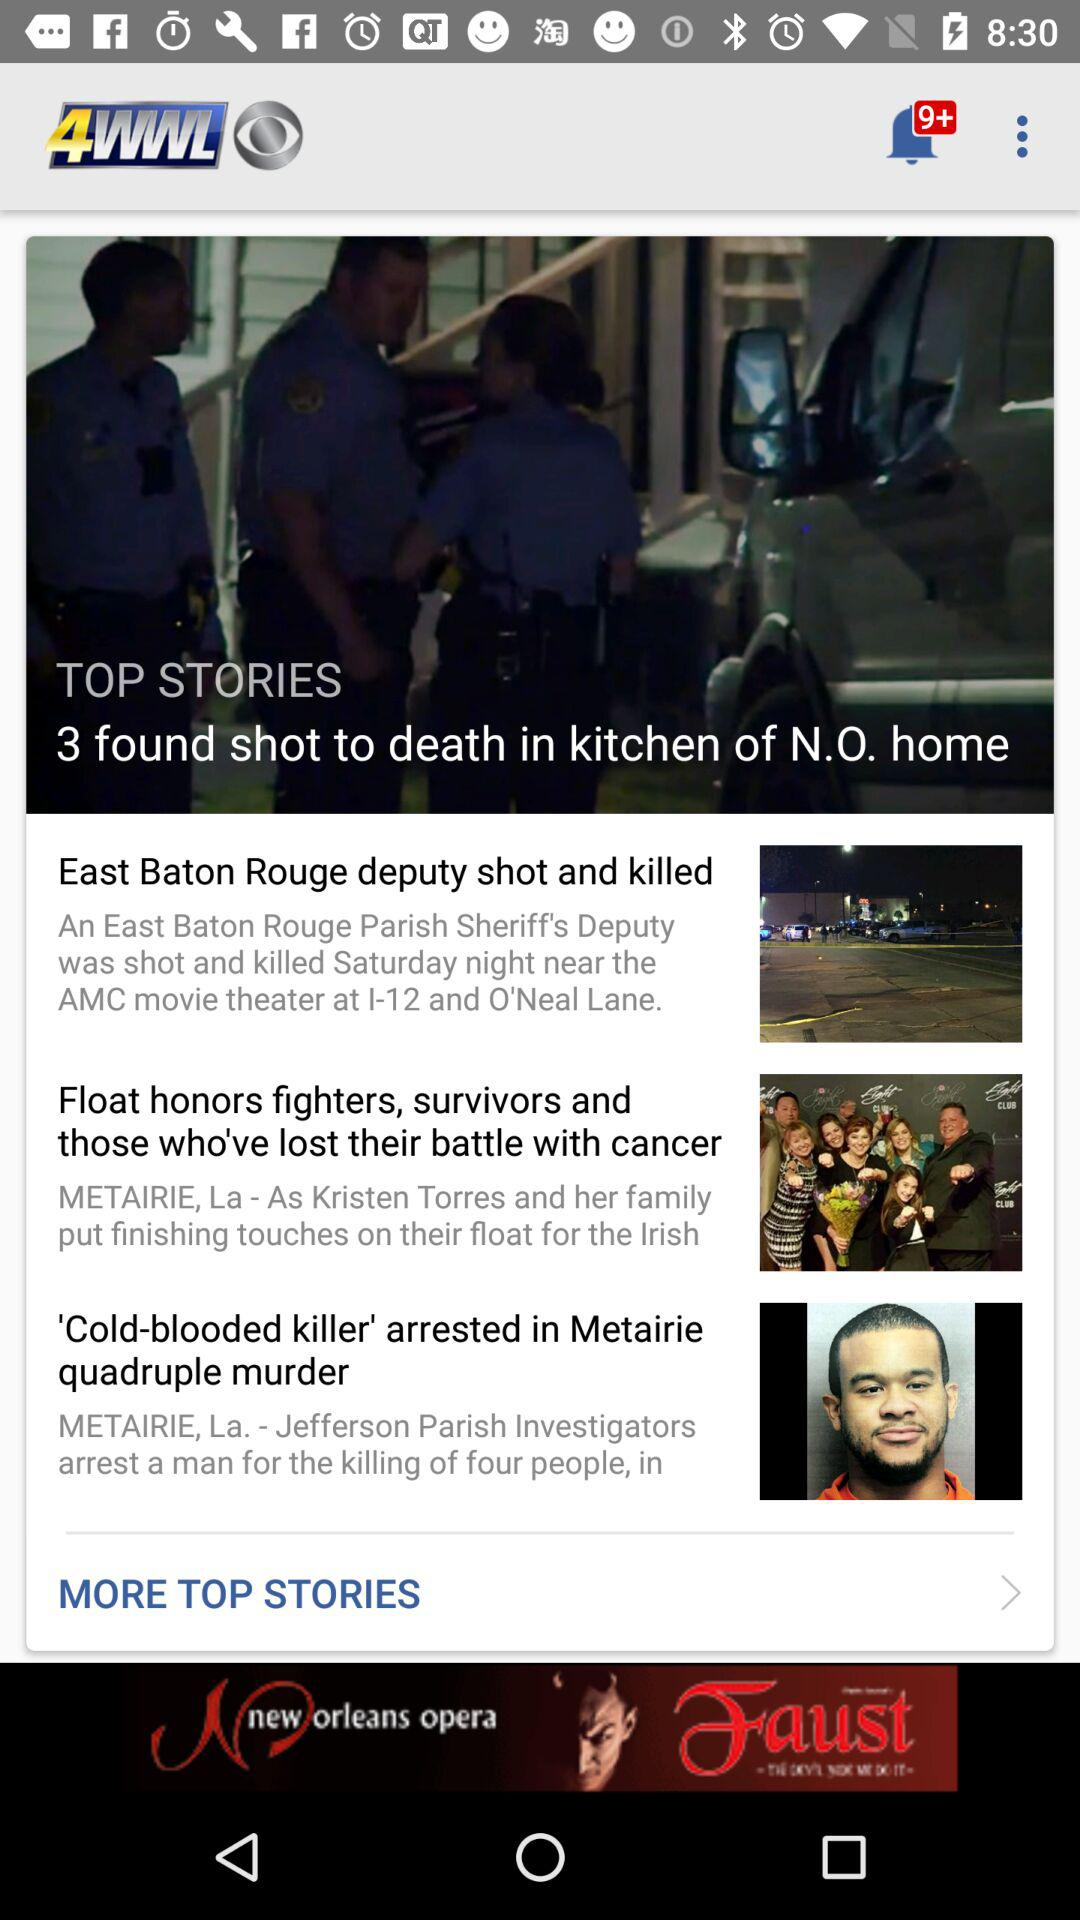How many stories are there in total?
Answer the question using a single word or phrase. 3 